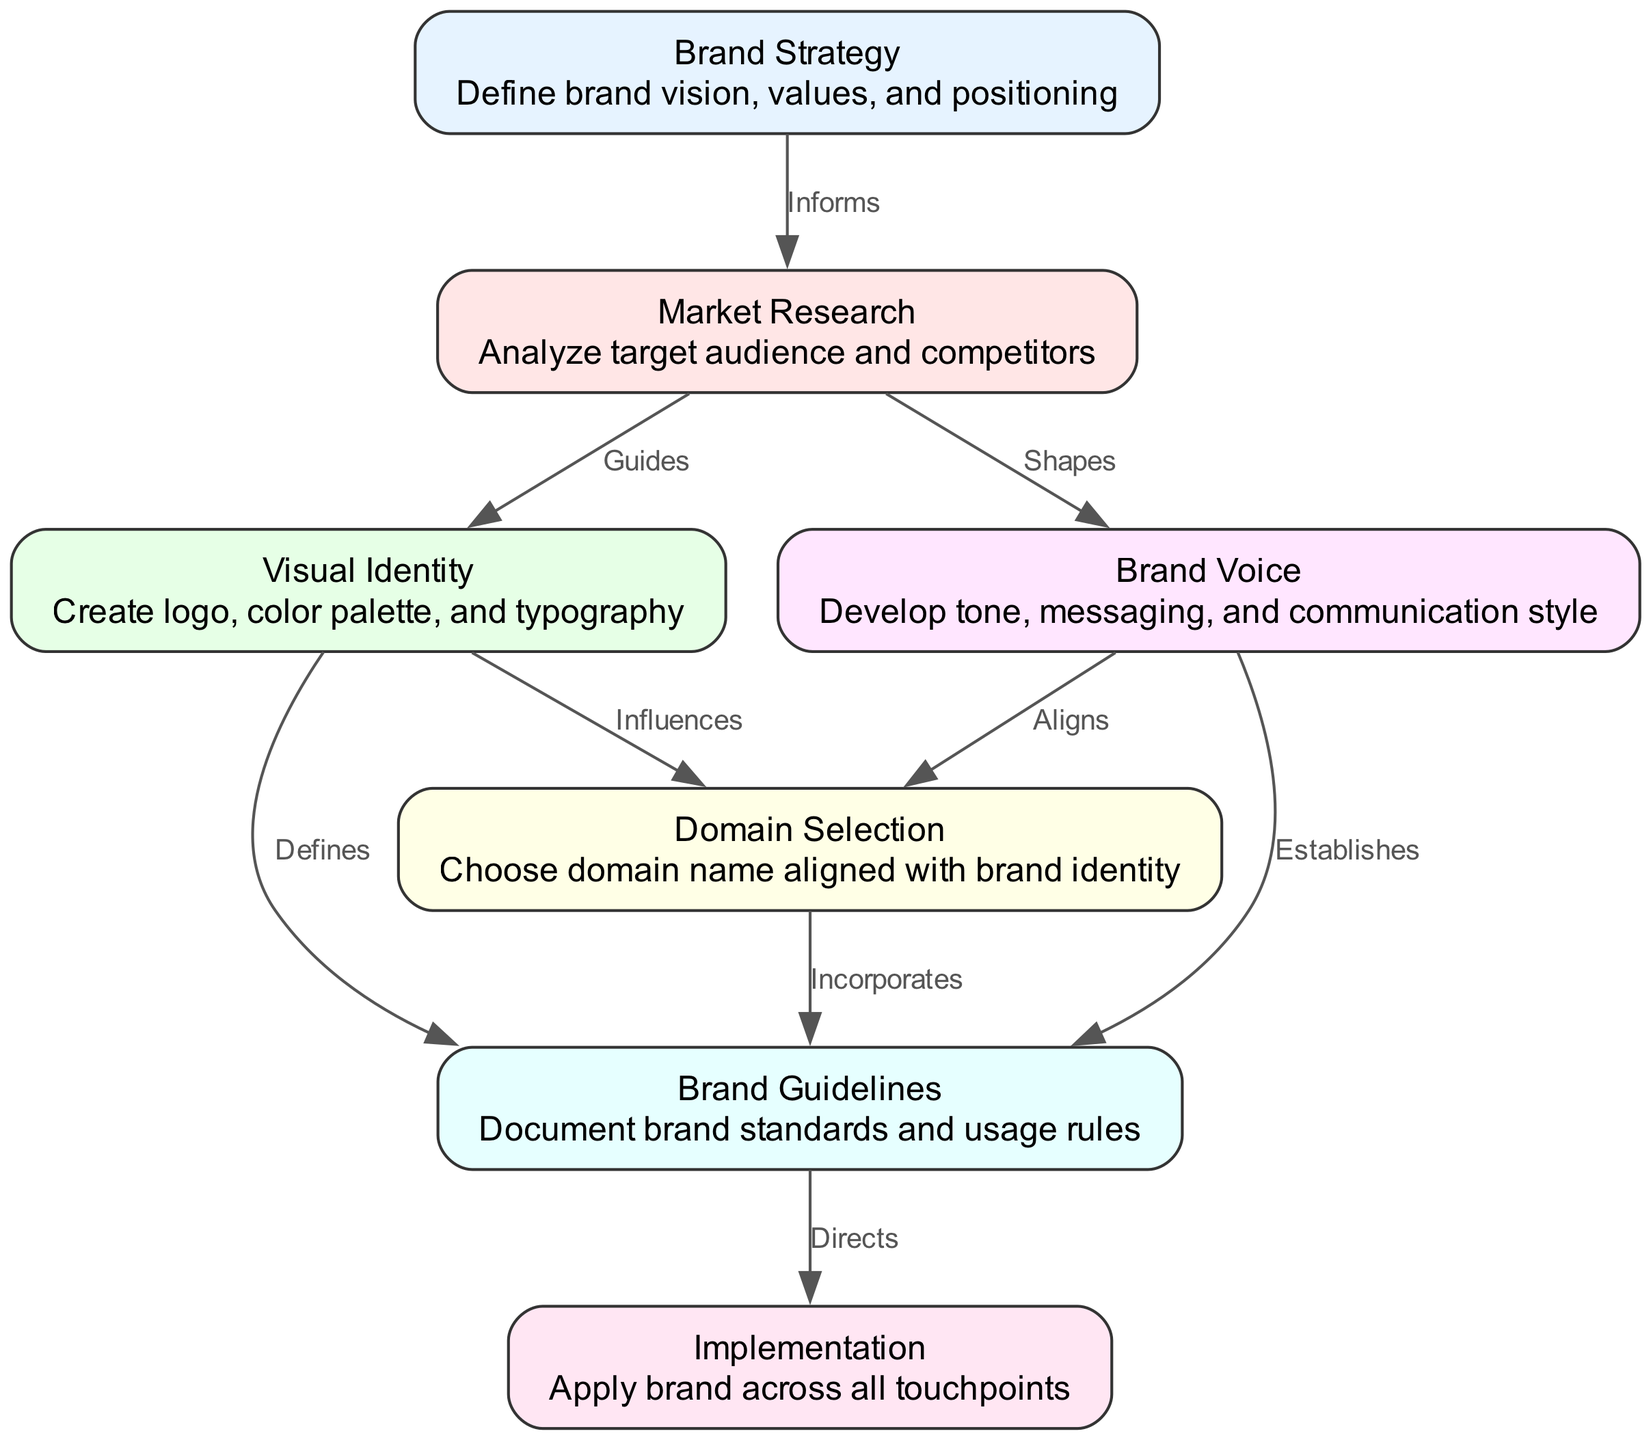What is the first stage in the brand identity development lifecycle? The diagram clearly shows that the first stage listed in the nodes is "Brand Strategy." This is the initial point of the lifecycle, as indicated by its position at the top of the block diagram.
Answer: Brand Strategy How many nodes are present in the diagram? By counting the elements under the "nodes" section of the data, there are a total of seven distinct stages represented in the diagram. Each node corresponds to a specific phase of the brand identity development lifecycle.
Answer: 7 What relationship does "Market Research" have with "Visual Identity"? The diagram illustrates that "Market Research" guides "Visual Identity," as indicated by the edge connecting these two nodes with the label "Guides." This shows the directional influence within the process.
Answer: Guides Which node directly influences "Domain Selection"? The "Visual Identity" node directly influences "Domain Selection," as they are connected in the diagram. The label on their connecting edge is "Influences," indicating that the visual elements affect the choice of domain.
Answer: Visual Identity What comes after "Brand Guidelines" in the lifecycle? According to the diagram, "Implementation" follows "Brand Guidelines" as indicated by the directional edge that connects these two stages. This reveals the order of operations in the lifecycle process.
Answer: Implementation How many edges are there that come from "Brand Voice"? There are two edges that originate from the "Brand Voice" node, as shown in the edges section of the data. These edges connect to "Domain Selection" and "Brand Guidelines," indicating its dual influence in the lifecycle.
Answer: 2 What is the main purpose of the "Brand Guidelines" stage? The diagram specifies that the purpose of "Brand Guidelines" is to document brand standards and usage rules, making this the primary function of this stage as described in the node's details.
Answer: Document brand standards Which two nodes are connected by the label "Directs"? The edge labeled "Directs" connects "Brand Guidelines" to "Implementation," showing the flow of action and indicating that the guidelines guide the implementation process across all touchpoints.
Answer: Brand Guidelines, Implementation 